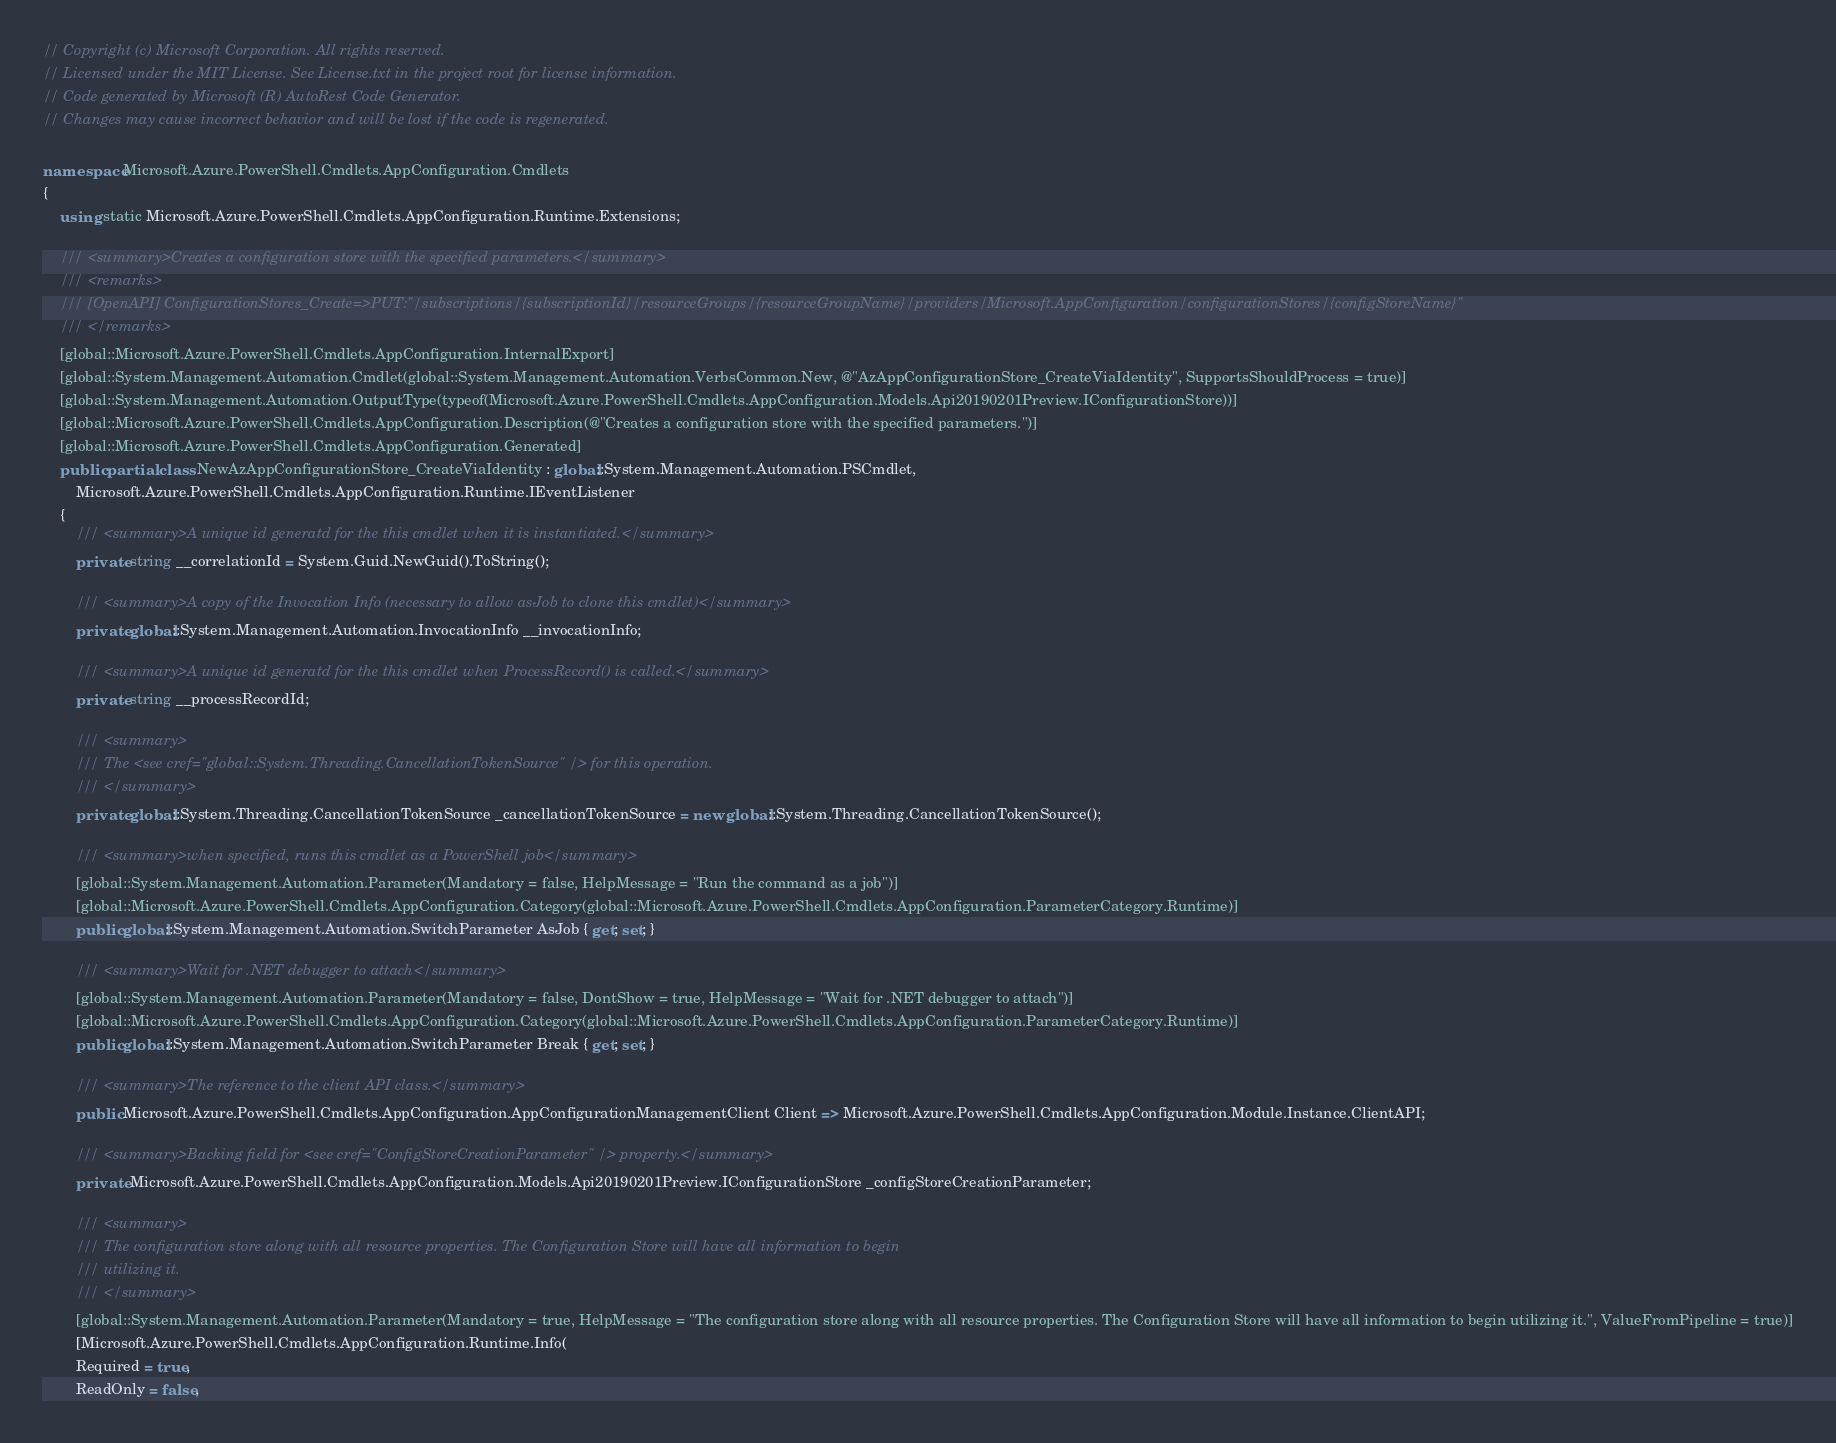<code> <loc_0><loc_0><loc_500><loc_500><_C#_>// Copyright (c) Microsoft Corporation. All rights reserved.
// Licensed under the MIT License. See License.txt in the project root for license information.
// Code generated by Microsoft (R) AutoRest Code Generator.
// Changes may cause incorrect behavior and will be lost if the code is regenerated.

namespace Microsoft.Azure.PowerShell.Cmdlets.AppConfiguration.Cmdlets
{
    using static Microsoft.Azure.PowerShell.Cmdlets.AppConfiguration.Runtime.Extensions;

    /// <summary>Creates a configuration store with the specified parameters.</summary>
    /// <remarks>
    /// [OpenAPI] ConfigurationStores_Create=>PUT:"/subscriptions/{subscriptionId}/resourceGroups/{resourceGroupName}/providers/Microsoft.AppConfiguration/configurationStores/{configStoreName}"
    /// </remarks>
    [global::Microsoft.Azure.PowerShell.Cmdlets.AppConfiguration.InternalExport]
    [global::System.Management.Automation.Cmdlet(global::System.Management.Automation.VerbsCommon.New, @"AzAppConfigurationStore_CreateViaIdentity", SupportsShouldProcess = true)]
    [global::System.Management.Automation.OutputType(typeof(Microsoft.Azure.PowerShell.Cmdlets.AppConfiguration.Models.Api20190201Preview.IConfigurationStore))]
    [global::Microsoft.Azure.PowerShell.Cmdlets.AppConfiguration.Description(@"Creates a configuration store with the specified parameters.")]
    [global::Microsoft.Azure.PowerShell.Cmdlets.AppConfiguration.Generated]
    public partial class NewAzAppConfigurationStore_CreateViaIdentity : global::System.Management.Automation.PSCmdlet,
        Microsoft.Azure.PowerShell.Cmdlets.AppConfiguration.Runtime.IEventListener
    {
        /// <summary>A unique id generatd for the this cmdlet when it is instantiated.</summary>
        private string __correlationId = System.Guid.NewGuid().ToString();

        /// <summary>A copy of the Invocation Info (necessary to allow asJob to clone this cmdlet)</summary>
        private global::System.Management.Automation.InvocationInfo __invocationInfo;

        /// <summary>A unique id generatd for the this cmdlet when ProcessRecord() is called.</summary>
        private string __processRecordId;

        /// <summary>
        /// The <see cref="global::System.Threading.CancellationTokenSource" /> for this operation.
        /// </summary>
        private global::System.Threading.CancellationTokenSource _cancellationTokenSource = new global::System.Threading.CancellationTokenSource();

        /// <summary>when specified, runs this cmdlet as a PowerShell job</summary>
        [global::System.Management.Automation.Parameter(Mandatory = false, HelpMessage = "Run the command as a job")]
        [global::Microsoft.Azure.PowerShell.Cmdlets.AppConfiguration.Category(global::Microsoft.Azure.PowerShell.Cmdlets.AppConfiguration.ParameterCategory.Runtime)]
        public global::System.Management.Automation.SwitchParameter AsJob { get; set; }

        /// <summary>Wait for .NET debugger to attach</summary>
        [global::System.Management.Automation.Parameter(Mandatory = false, DontShow = true, HelpMessage = "Wait for .NET debugger to attach")]
        [global::Microsoft.Azure.PowerShell.Cmdlets.AppConfiguration.Category(global::Microsoft.Azure.PowerShell.Cmdlets.AppConfiguration.ParameterCategory.Runtime)]
        public global::System.Management.Automation.SwitchParameter Break { get; set; }

        /// <summary>The reference to the client API class.</summary>
        public Microsoft.Azure.PowerShell.Cmdlets.AppConfiguration.AppConfigurationManagementClient Client => Microsoft.Azure.PowerShell.Cmdlets.AppConfiguration.Module.Instance.ClientAPI;

        /// <summary>Backing field for <see cref="ConfigStoreCreationParameter" /> property.</summary>
        private Microsoft.Azure.PowerShell.Cmdlets.AppConfiguration.Models.Api20190201Preview.IConfigurationStore _configStoreCreationParameter;

        /// <summary>
        /// The configuration store along with all resource properties. The Configuration Store will have all information to begin
        /// utilizing it.
        /// </summary>
        [global::System.Management.Automation.Parameter(Mandatory = true, HelpMessage = "The configuration store along with all resource properties. The Configuration Store will have all information to begin utilizing it.", ValueFromPipeline = true)]
        [Microsoft.Azure.PowerShell.Cmdlets.AppConfiguration.Runtime.Info(
        Required = true,
        ReadOnly = false,</code> 